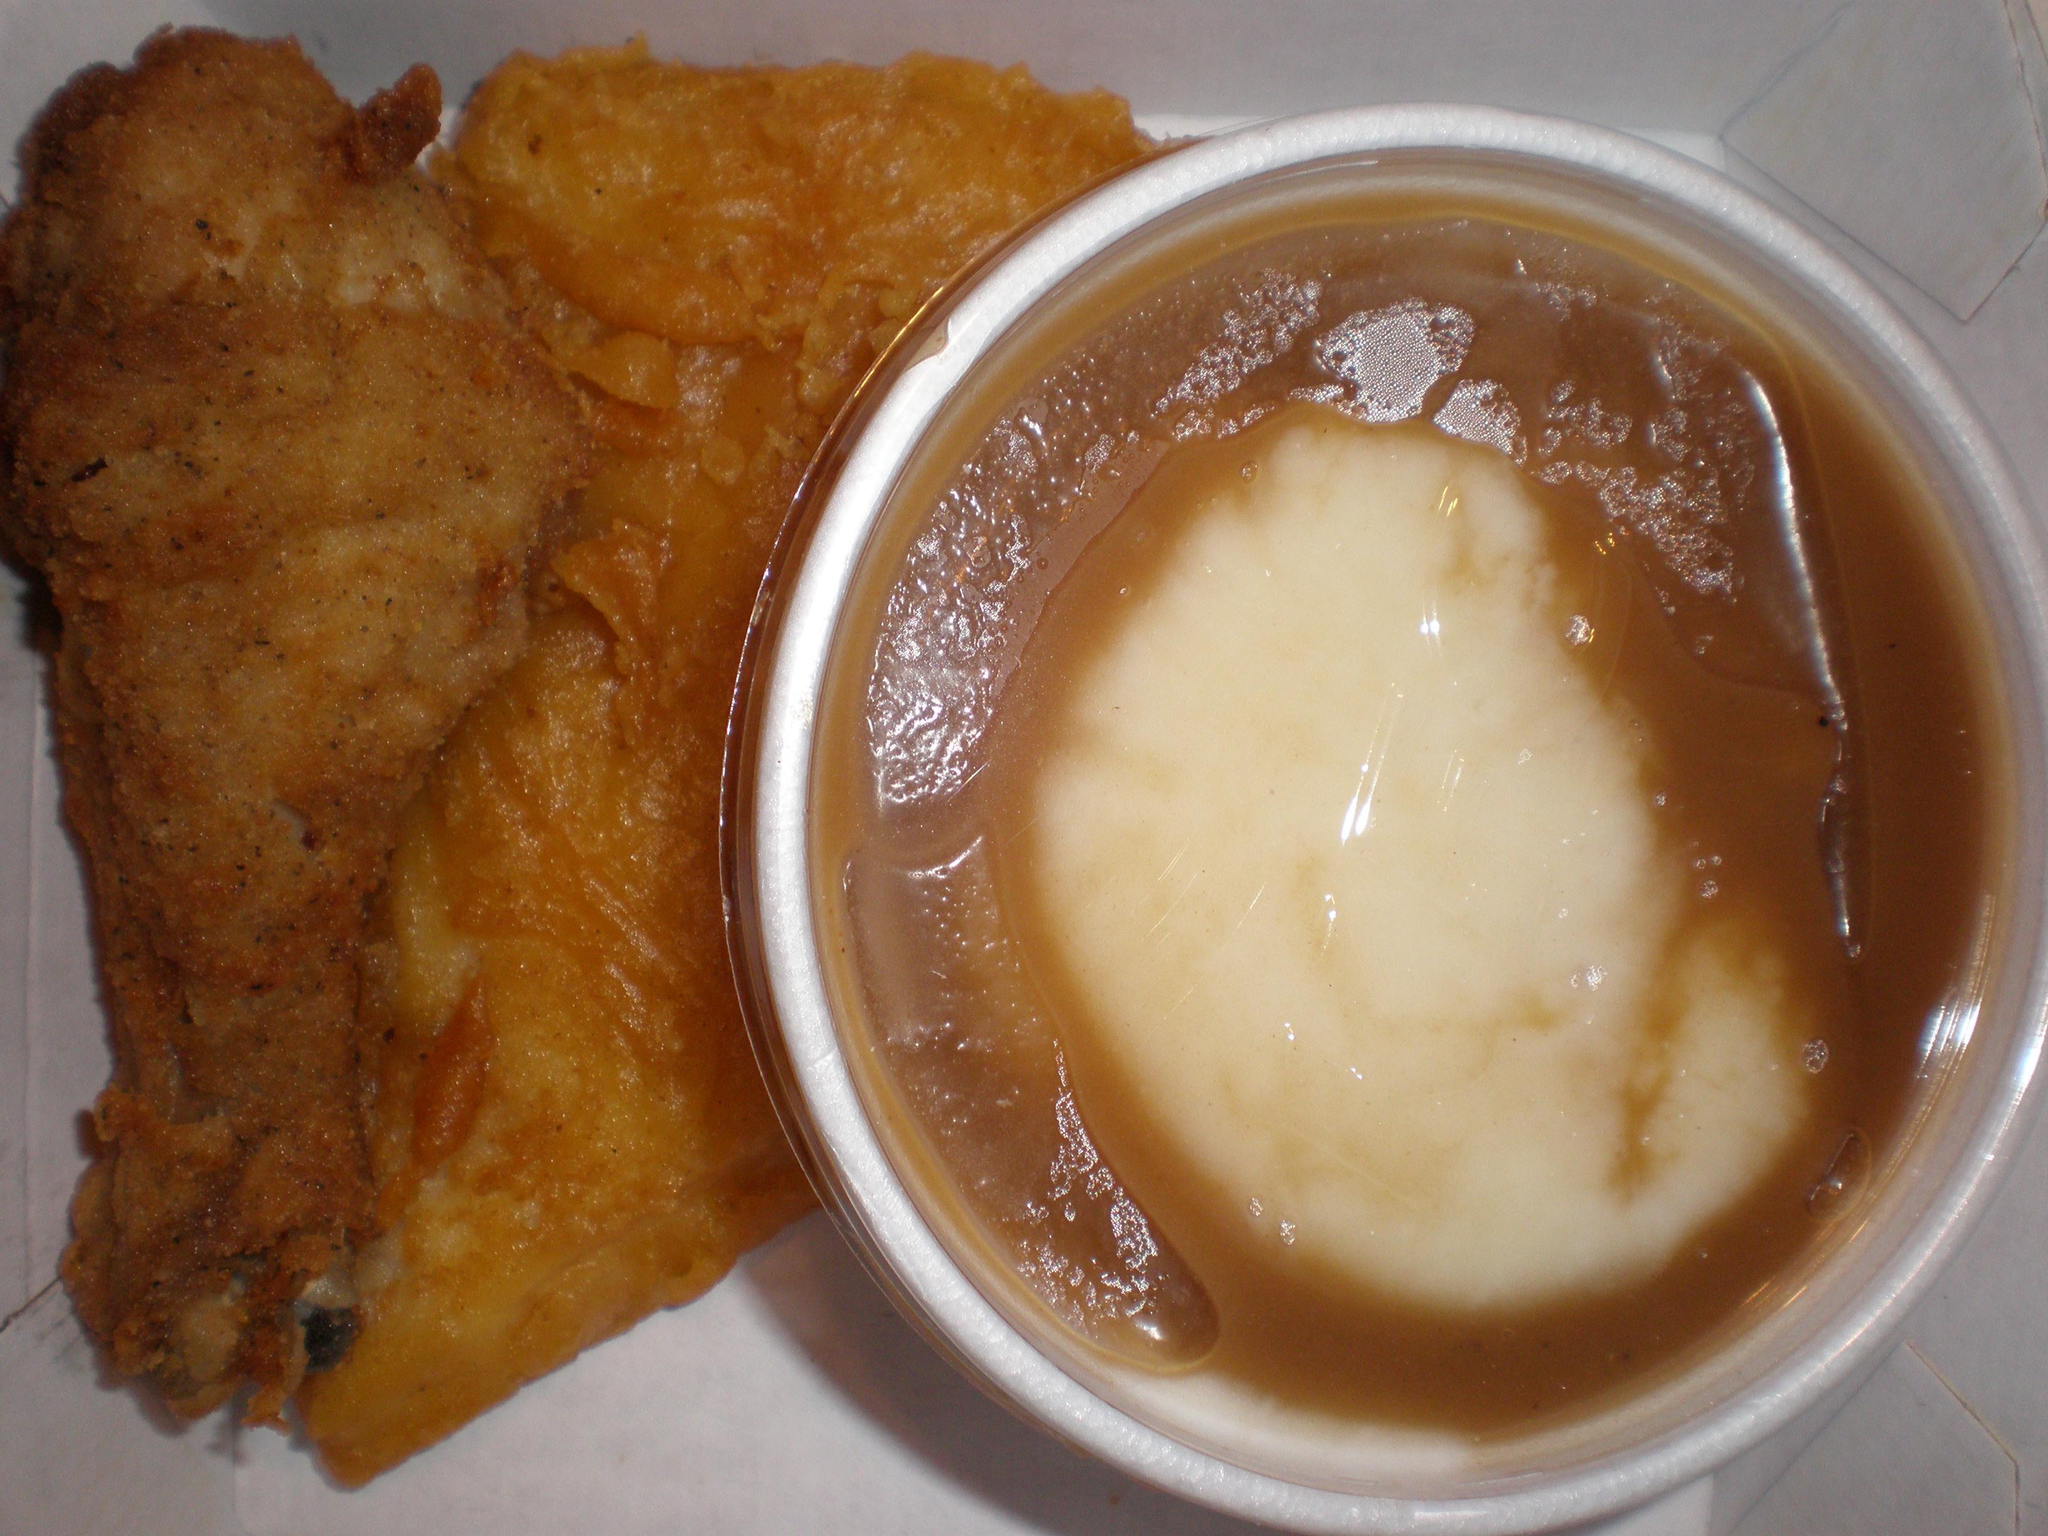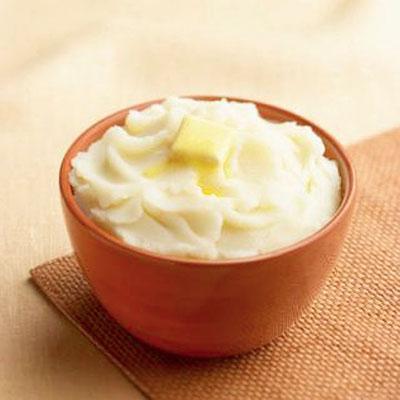The first image is the image on the left, the second image is the image on the right. Evaluate the accuracy of this statement regarding the images: "The mashed potatoes on the right picture has a spoon in its container.". Is it true? Answer yes or no. No. The first image is the image on the left, the second image is the image on the right. Analyze the images presented: Is the assertion "There is a utensil in the right hand image." valid? Answer yes or no. No. 